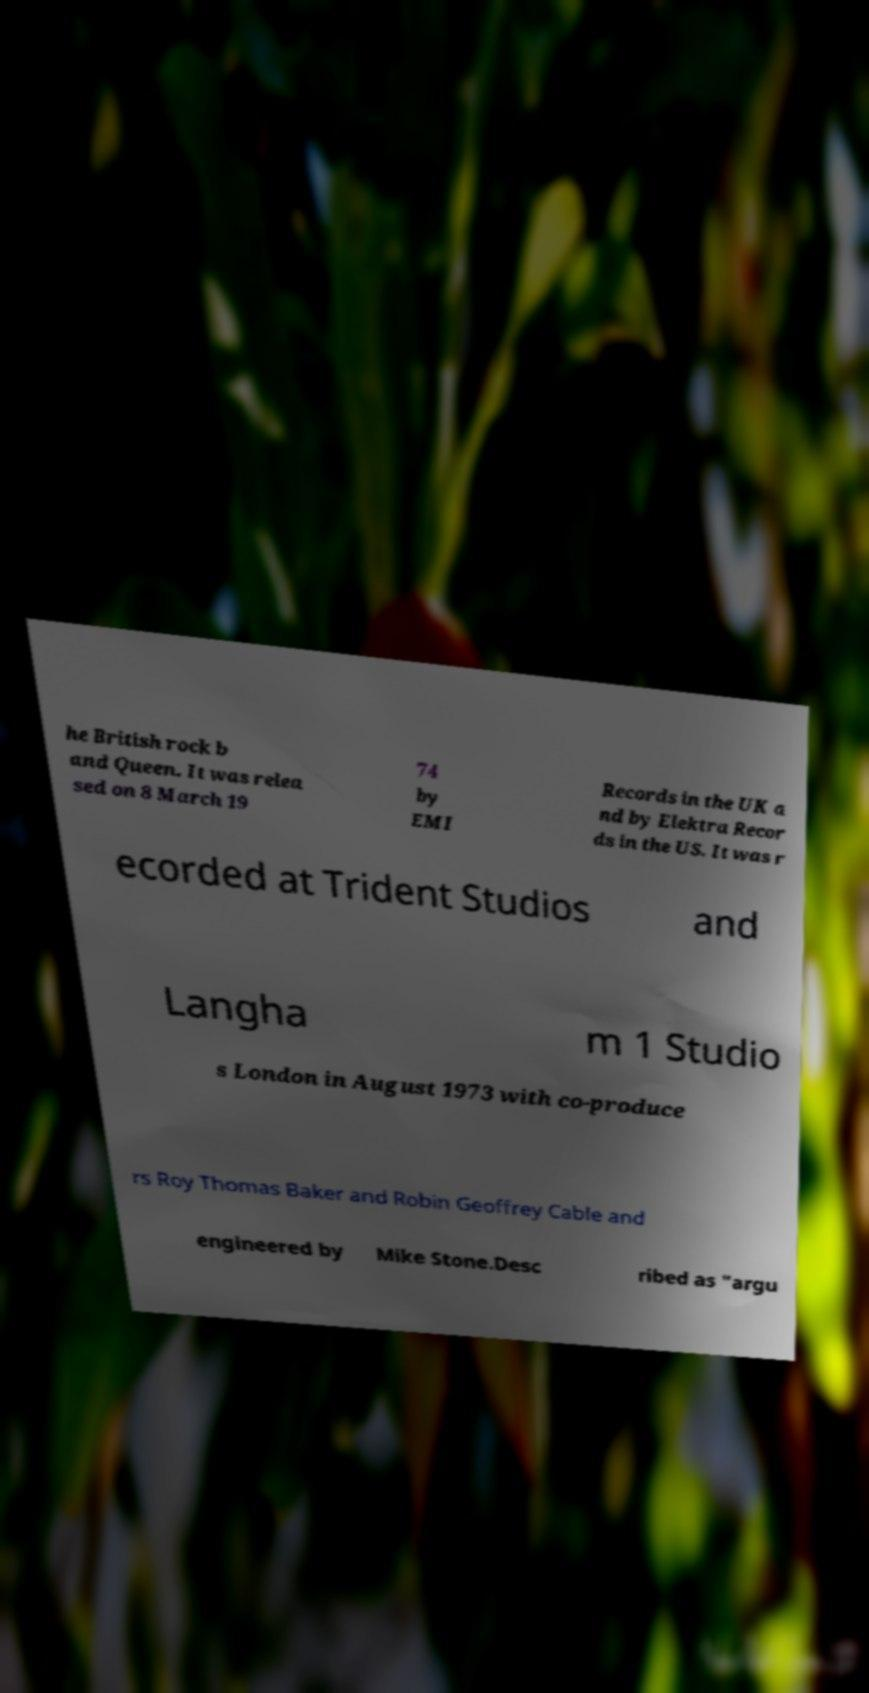Please identify and transcribe the text found in this image. he British rock b and Queen. It was relea sed on 8 March 19 74 by EMI Records in the UK a nd by Elektra Recor ds in the US. It was r ecorded at Trident Studios and Langha m 1 Studio s London in August 1973 with co-produce rs Roy Thomas Baker and Robin Geoffrey Cable and engineered by Mike Stone.Desc ribed as "argu 